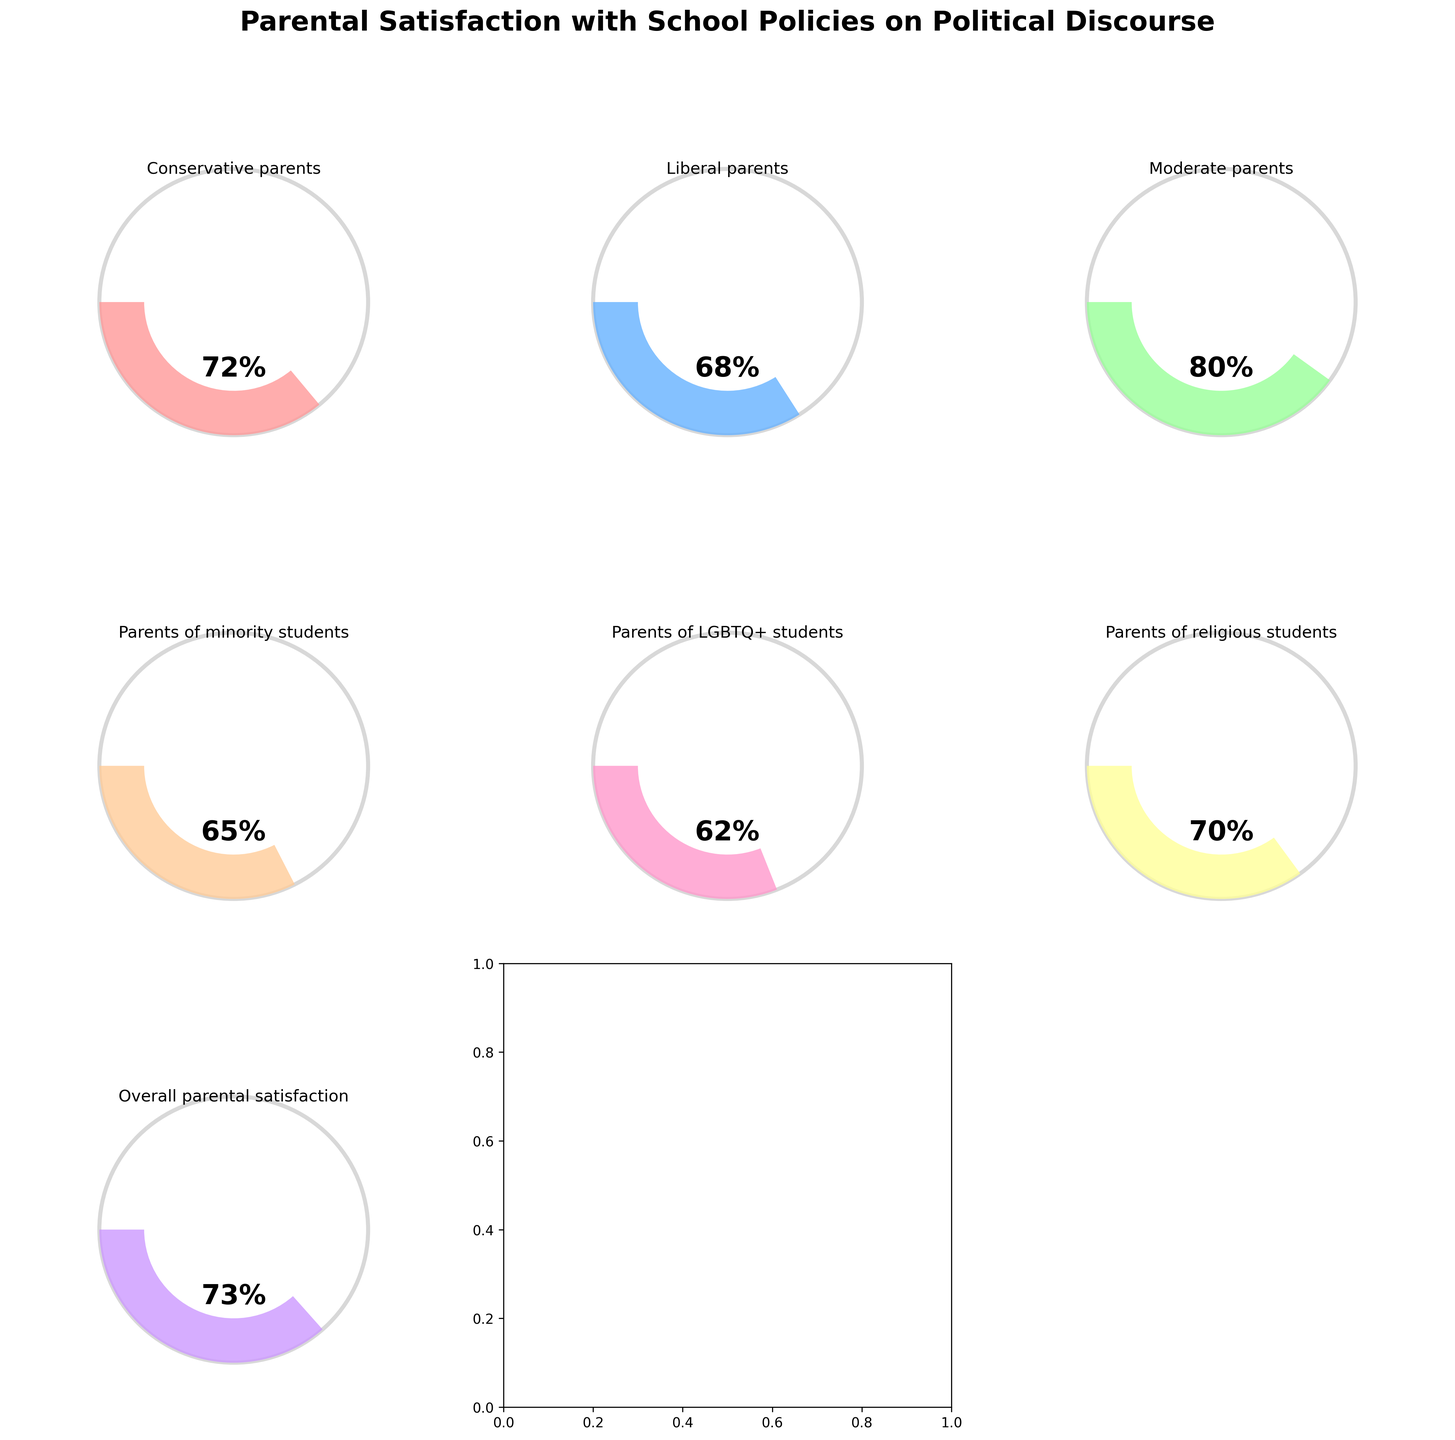What is the overall parental satisfaction with school policies on political discourse? The overall parental satisfaction is directly shown in the gauge chart labeled 'Overall parental satisfaction' with a value of 73%.
Answer: 73% Which category has the highest satisfaction rating? By comparing the values shown in each gauge chart, the category with 'Moderate parents' has the highest satisfaction rating at 80%.
Answer: Moderate parents What is the satisfaction rating for parents of LGBTQ+ students? The satisfaction rating is shown in the gauge chart labeled 'Parents of LGBTQ+ students' with a value of 62%.
Answer: 62% Which group has a higher satisfaction rating, Conservative parents or Liberal parents? By comparing the gauge charts of 'Conservative parents' (72%) and 'Liberal parents' (68%), 'Conservative parents' have a higher satisfaction rating.
Answer: Conservative parents What is the average satisfaction rating across all categories? To find the average: sum all satisfaction values (72 + 68 + 80 + 65 + 62 + 70 + 73) and divide by the number of categories (7). (490 / 7)
Answer: 70 How much higher is the satisfaction rating of Moderate parents compared to Parents of minority students? Compare the values: 80% (Moderate parents) - 65% (Parents of minority students) = 15%.
Answer: 15% Based on the chart, are there any categories with satisfaction ratings below 65%? By inspecting each gauge chart, 'Parents of LGBTQ+ students' is the only category below 65%, with a rating of 62%.
Answer: Yes, Parents of LGBTQ+ students Which categories have satisfaction ratings greater than 70%? 'Conservative parents' (72%), 'Moderate parents' (80%), 'Parents of religious students' (70%), and 'Overall parental satisfaction' (73%) have ratings greater than 70%.
Answer: Conservative parents, Moderate parents, Parents of religious students, Overall parental satisfaction What is the difference in satisfaction ratings between Parents of religious students and Parents of LGBTQ+ students? The satisfaction rating for 'Parents of religious students' is 70%, and for 'Parents of LGBTQ+ students' is 62%. The difference is 70% - 62% = 8%.
Answer: 8% How many categories have a satisfaction rating between 60% and 70%? By inspecting each gauge chart, 'Liberal parents' (68%), 'Parents of minority students' (65%), and 'Parents of LGBTQ+ students' (62%) fall within this range. There are 3 such categories.
Answer: 3 